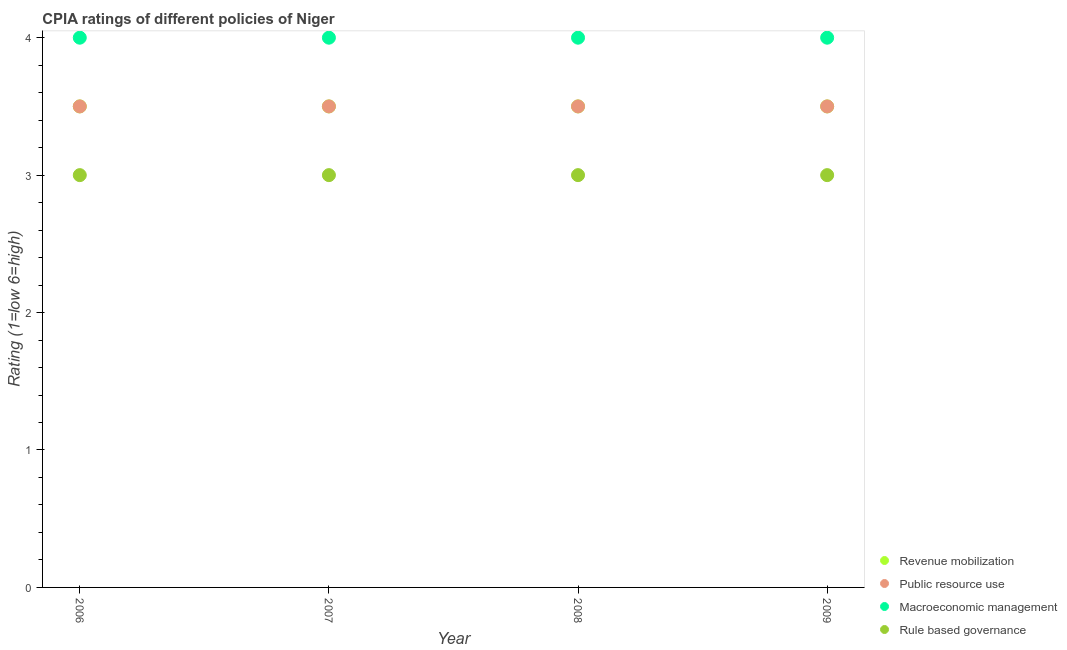How many different coloured dotlines are there?
Your answer should be compact. 4. What is the cpia rating of rule based governance in 2006?
Your response must be concise. 3. Across all years, what is the minimum cpia rating of revenue mobilization?
Make the answer very short. 3.5. In which year was the cpia rating of public resource use maximum?
Your response must be concise. 2006. In which year was the cpia rating of revenue mobilization minimum?
Provide a short and direct response. 2006. What is the total cpia rating of rule based governance in the graph?
Give a very brief answer. 12. What is the difference between the cpia rating of revenue mobilization in 2008 and that in 2009?
Your answer should be very brief. 0. Is the cpia rating of public resource use in 2006 less than that in 2008?
Give a very brief answer. No. What is the difference between the highest and the second highest cpia rating of macroeconomic management?
Make the answer very short. 0. What is the difference between the highest and the lowest cpia rating of revenue mobilization?
Ensure brevity in your answer.  0. In how many years, is the cpia rating of revenue mobilization greater than the average cpia rating of revenue mobilization taken over all years?
Make the answer very short. 0. Is the sum of the cpia rating of rule based governance in 2007 and 2008 greater than the maximum cpia rating of macroeconomic management across all years?
Keep it short and to the point. Yes. Is the cpia rating of revenue mobilization strictly greater than the cpia rating of macroeconomic management over the years?
Provide a short and direct response. No. How many years are there in the graph?
Make the answer very short. 4. Does the graph contain grids?
Your answer should be compact. No. What is the title of the graph?
Your answer should be very brief. CPIA ratings of different policies of Niger. What is the label or title of the X-axis?
Offer a very short reply. Year. What is the Rating (1=low 6=high) of Public resource use in 2006?
Your answer should be very brief. 3.5. What is the Rating (1=low 6=high) in Macroeconomic management in 2006?
Your response must be concise. 4. What is the Rating (1=low 6=high) in Public resource use in 2007?
Your answer should be very brief. 3.5. What is the Rating (1=low 6=high) of Macroeconomic management in 2007?
Your answer should be compact. 4. What is the Rating (1=low 6=high) of Rule based governance in 2007?
Your answer should be very brief. 3. What is the Rating (1=low 6=high) of Revenue mobilization in 2008?
Provide a succinct answer. 3.5. What is the Rating (1=low 6=high) of Public resource use in 2008?
Ensure brevity in your answer.  3.5. What is the Rating (1=low 6=high) in Rule based governance in 2008?
Ensure brevity in your answer.  3. Across all years, what is the maximum Rating (1=low 6=high) of Revenue mobilization?
Keep it short and to the point. 3.5. Across all years, what is the maximum Rating (1=low 6=high) in Rule based governance?
Provide a succinct answer. 3. Across all years, what is the minimum Rating (1=low 6=high) in Revenue mobilization?
Your answer should be very brief. 3.5. Across all years, what is the minimum Rating (1=low 6=high) in Macroeconomic management?
Make the answer very short. 4. Across all years, what is the minimum Rating (1=low 6=high) in Rule based governance?
Your answer should be compact. 3. What is the total Rating (1=low 6=high) of Macroeconomic management in the graph?
Provide a succinct answer. 16. What is the total Rating (1=low 6=high) in Rule based governance in the graph?
Provide a short and direct response. 12. What is the difference between the Rating (1=low 6=high) in Revenue mobilization in 2006 and that in 2007?
Offer a very short reply. 0. What is the difference between the Rating (1=low 6=high) in Macroeconomic management in 2006 and that in 2007?
Provide a short and direct response. 0. What is the difference between the Rating (1=low 6=high) of Rule based governance in 2006 and that in 2007?
Provide a succinct answer. 0. What is the difference between the Rating (1=low 6=high) of Public resource use in 2006 and that in 2008?
Provide a short and direct response. 0. What is the difference between the Rating (1=low 6=high) of Public resource use in 2006 and that in 2009?
Ensure brevity in your answer.  0. What is the difference between the Rating (1=low 6=high) of Macroeconomic management in 2006 and that in 2009?
Give a very brief answer. 0. What is the difference between the Rating (1=low 6=high) of Rule based governance in 2007 and that in 2008?
Provide a succinct answer. 0. What is the difference between the Rating (1=low 6=high) of Public resource use in 2007 and that in 2009?
Give a very brief answer. 0. What is the difference between the Rating (1=low 6=high) in Rule based governance in 2007 and that in 2009?
Give a very brief answer. 0. What is the difference between the Rating (1=low 6=high) in Public resource use in 2008 and that in 2009?
Give a very brief answer. 0. What is the difference between the Rating (1=low 6=high) of Macroeconomic management in 2008 and that in 2009?
Your answer should be very brief. 0. What is the difference between the Rating (1=low 6=high) in Revenue mobilization in 2006 and the Rating (1=low 6=high) in Macroeconomic management in 2007?
Provide a succinct answer. -0.5. What is the difference between the Rating (1=low 6=high) in Public resource use in 2006 and the Rating (1=low 6=high) in Macroeconomic management in 2007?
Provide a short and direct response. -0.5. What is the difference between the Rating (1=low 6=high) of Public resource use in 2006 and the Rating (1=low 6=high) of Rule based governance in 2007?
Provide a succinct answer. 0.5. What is the difference between the Rating (1=low 6=high) of Revenue mobilization in 2006 and the Rating (1=low 6=high) of Public resource use in 2008?
Your answer should be very brief. 0. What is the difference between the Rating (1=low 6=high) in Revenue mobilization in 2006 and the Rating (1=low 6=high) in Macroeconomic management in 2008?
Offer a terse response. -0.5. What is the difference between the Rating (1=low 6=high) of Revenue mobilization in 2006 and the Rating (1=low 6=high) of Rule based governance in 2008?
Offer a terse response. 0.5. What is the difference between the Rating (1=low 6=high) of Public resource use in 2006 and the Rating (1=low 6=high) of Macroeconomic management in 2008?
Ensure brevity in your answer.  -0.5. What is the difference between the Rating (1=low 6=high) in Public resource use in 2006 and the Rating (1=low 6=high) in Rule based governance in 2008?
Give a very brief answer. 0.5. What is the difference between the Rating (1=low 6=high) in Macroeconomic management in 2006 and the Rating (1=low 6=high) in Rule based governance in 2008?
Provide a succinct answer. 1. What is the difference between the Rating (1=low 6=high) in Revenue mobilization in 2006 and the Rating (1=low 6=high) in Macroeconomic management in 2009?
Your response must be concise. -0.5. What is the difference between the Rating (1=low 6=high) of Public resource use in 2006 and the Rating (1=low 6=high) of Rule based governance in 2009?
Make the answer very short. 0.5. What is the difference between the Rating (1=low 6=high) in Revenue mobilization in 2007 and the Rating (1=low 6=high) in Public resource use in 2008?
Ensure brevity in your answer.  0. What is the difference between the Rating (1=low 6=high) in Revenue mobilization in 2007 and the Rating (1=low 6=high) in Macroeconomic management in 2008?
Your answer should be very brief. -0.5. What is the difference between the Rating (1=low 6=high) in Revenue mobilization in 2007 and the Rating (1=low 6=high) in Rule based governance in 2008?
Make the answer very short. 0.5. What is the difference between the Rating (1=low 6=high) in Public resource use in 2007 and the Rating (1=low 6=high) in Macroeconomic management in 2008?
Provide a succinct answer. -0.5. What is the difference between the Rating (1=low 6=high) in Macroeconomic management in 2007 and the Rating (1=low 6=high) in Rule based governance in 2008?
Your response must be concise. 1. What is the difference between the Rating (1=low 6=high) in Revenue mobilization in 2007 and the Rating (1=low 6=high) in Public resource use in 2009?
Ensure brevity in your answer.  0. What is the difference between the Rating (1=low 6=high) of Revenue mobilization in 2007 and the Rating (1=low 6=high) of Macroeconomic management in 2009?
Offer a very short reply. -0.5. What is the difference between the Rating (1=low 6=high) in Public resource use in 2007 and the Rating (1=low 6=high) in Rule based governance in 2009?
Keep it short and to the point. 0.5. What is the difference between the Rating (1=low 6=high) of Revenue mobilization in 2008 and the Rating (1=low 6=high) of Macroeconomic management in 2009?
Make the answer very short. -0.5. What is the difference between the Rating (1=low 6=high) in Public resource use in 2008 and the Rating (1=low 6=high) in Rule based governance in 2009?
Make the answer very short. 0.5. What is the average Rating (1=low 6=high) of Revenue mobilization per year?
Offer a very short reply. 3.5. What is the average Rating (1=low 6=high) in Public resource use per year?
Give a very brief answer. 3.5. In the year 2006, what is the difference between the Rating (1=low 6=high) of Revenue mobilization and Rating (1=low 6=high) of Public resource use?
Offer a terse response. 0. In the year 2006, what is the difference between the Rating (1=low 6=high) in Revenue mobilization and Rating (1=low 6=high) in Rule based governance?
Offer a terse response. 0.5. In the year 2006, what is the difference between the Rating (1=low 6=high) of Public resource use and Rating (1=low 6=high) of Macroeconomic management?
Your answer should be very brief. -0.5. In the year 2006, what is the difference between the Rating (1=low 6=high) of Public resource use and Rating (1=low 6=high) of Rule based governance?
Provide a succinct answer. 0.5. In the year 2007, what is the difference between the Rating (1=low 6=high) in Revenue mobilization and Rating (1=low 6=high) in Public resource use?
Your response must be concise. 0. In the year 2007, what is the difference between the Rating (1=low 6=high) of Revenue mobilization and Rating (1=low 6=high) of Macroeconomic management?
Offer a very short reply. -0.5. In the year 2008, what is the difference between the Rating (1=low 6=high) in Revenue mobilization and Rating (1=low 6=high) in Public resource use?
Make the answer very short. 0. In the year 2008, what is the difference between the Rating (1=low 6=high) of Macroeconomic management and Rating (1=low 6=high) of Rule based governance?
Give a very brief answer. 1. In the year 2009, what is the difference between the Rating (1=low 6=high) of Revenue mobilization and Rating (1=low 6=high) of Public resource use?
Offer a terse response. 0. In the year 2009, what is the difference between the Rating (1=low 6=high) in Revenue mobilization and Rating (1=low 6=high) in Rule based governance?
Ensure brevity in your answer.  0.5. In the year 2009, what is the difference between the Rating (1=low 6=high) in Public resource use and Rating (1=low 6=high) in Rule based governance?
Provide a succinct answer. 0.5. What is the ratio of the Rating (1=low 6=high) of Revenue mobilization in 2006 to that in 2008?
Your answer should be compact. 1. What is the ratio of the Rating (1=low 6=high) of Macroeconomic management in 2006 to that in 2008?
Keep it short and to the point. 1. What is the ratio of the Rating (1=low 6=high) in Public resource use in 2006 to that in 2009?
Provide a succinct answer. 1. What is the ratio of the Rating (1=low 6=high) in Macroeconomic management in 2006 to that in 2009?
Offer a terse response. 1. What is the ratio of the Rating (1=low 6=high) in Revenue mobilization in 2007 to that in 2008?
Provide a short and direct response. 1. What is the ratio of the Rating (1=low 6=high) in Public resource use in 2007 to that in 2009?
Make the answer very short. 1. What is the ratio of the Rating (1=low 6=high) in Macroeconomic management in 2007 to that in 2009?
Offer a very short reply. 1. What is the ratio of the Rating (1=low 6=high) of Rule based governance in 2007 to that in 2009?
Provide a succinct answer. 1. What is the ratio of the Rating (1=low 6=high) in Revenue mobilization in 2008 to that in 2009?
Offer a very short reply. 1. What is the ratio of the Rating (1=low 6=high) of Public resource use in 2008 to that in 2009?
Your answer should be very brief. 1. What is the difference between the highest and the second highest Rating (1=low 6=high) of Revenue mobilization?
Offer a terse response. 0. What is the difference between the highest and the second highest Rating (1=low 6=high) of Public resource use?
Your response must be concise. 0. What is the difference between the highest and the second highest Rating (1=low 6=high) of Macroeconomic management?
Offer a terse response. 0. What is the difference between the highest and the lowest Rating (1=low 6=high) in Revenue mobilization?
Keep it short and to the point. 0. What is the difference between the highest and the lowest Rating (1=low 6=high) of Macroeconomic management?
Your response must be concise. 0. What is the difference between the highest and the lowest Rating (1=low 6=high) in Rule based governance?
Provide a succinct answer. 0. 